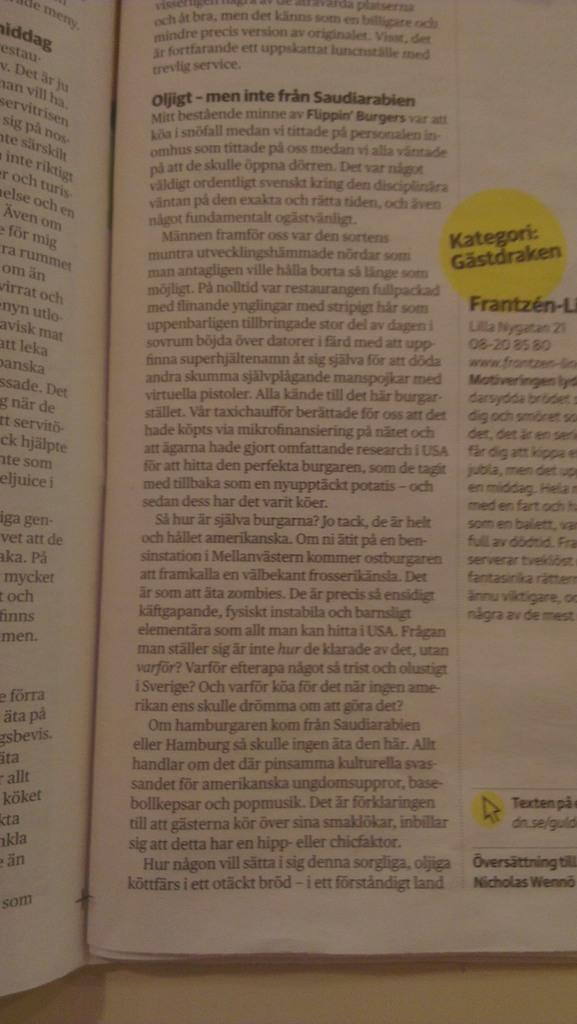Provide a one-sentence caption for the provided image. A textbook open to a page titled Kategori: Gastdraken. 